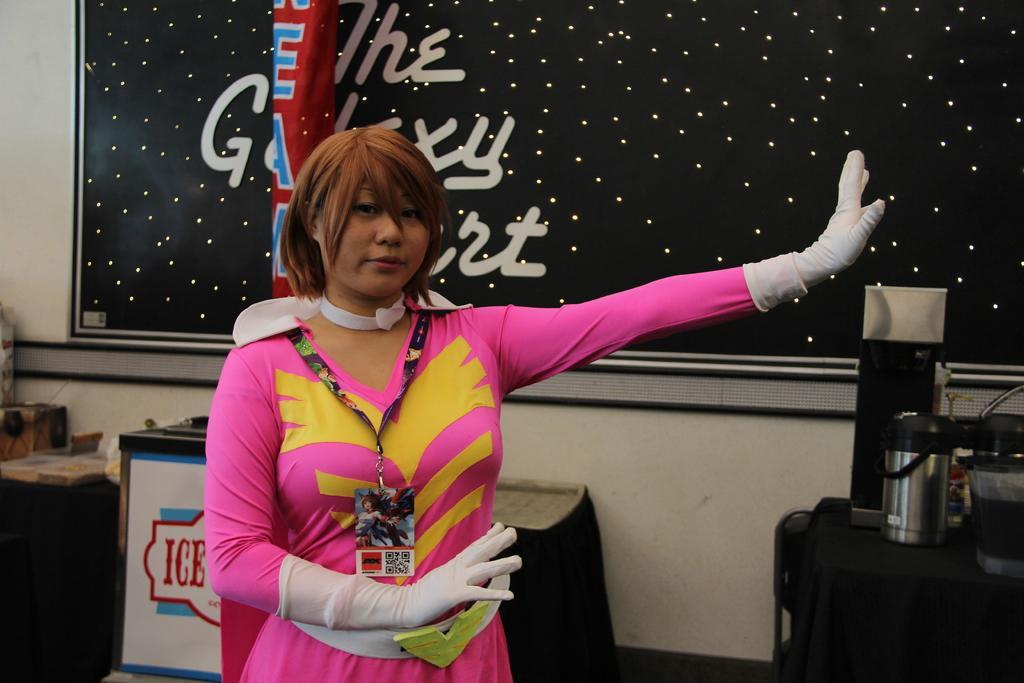How would you summarize this image in a sentence or two? A person is standing wearing a pink dress, white gloves and an id card. There are tables at the back and there is a black board. 